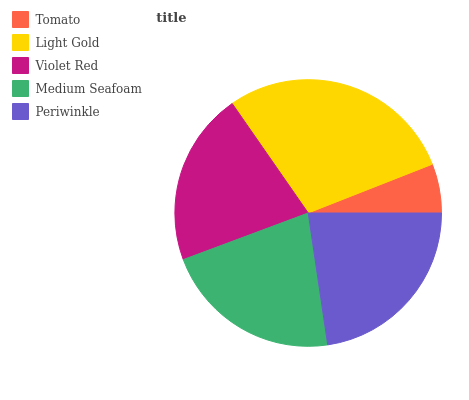Is Tomato the minimum?
Answer yes or no. Yes. Is Light Gold the maximum?
Answer yes or no. Yes. Is Violet Red the minimum?
Answer yes or no. No. Is Violet Red the maximum?
Answer yes or no. No. Is Light Gold greater than Violet Red?
Answer yes or no. Yes. Is Violet Red less than Light Gold?
Answer yes or no. Yes. Is Violet Red greater than Light Gold?
Answer yes or no. No. Is Light Gold less than Violet Red?
Answer yes or no. No. Is Medium Seafoam the high median?
Answer yes or no. Yes. Is Medium Seafoam the low median?
Answer yes or no. Yes. Is Light Gold the high median?
Answer yes or no. No. Is Light Gold the low median?
Answer yes or no. No. 